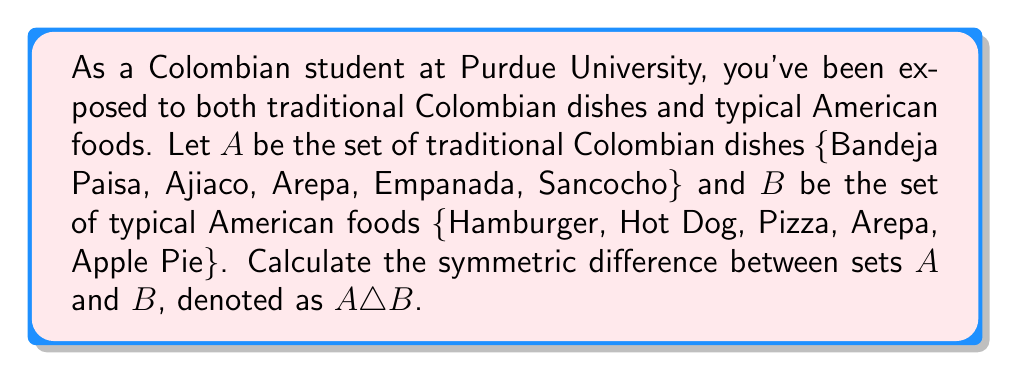What is the answer to this math problem? To solve this problem, we need to follow these steps:

1. Recall the definition of symmetric difference:
   The symmetric difference of two sets $A$ and $B$, denoted as $A \triangle B$, is the set of elements that are in either $A$ or $B$, but not in both.

2. Mathematically, this can be expressed as:
   $A \triangle B = (A \setminus B) \cup (B \setminus A)$
   where $\setminus$ denotes set difference.

3. Let's identify the elements in each set:
   $A = \{Bandeja Paisa, Ajiaco, Arepa, Empanada, Sancocho\}$
   $B = \{Hamburger, Hot Dog, Pizza, Arepa, Apple Pie\}$

4. Find $A \setminus B$ (elements in $A$ but not in $B$):
   $A \setminus B = \{Bandeja Paisa, Ajiaco, Empanada, Sancocho\}$

5. Find $B \setminus A$ (elements in $B$ but not in $A$):
   $B \setminus A = \{Hamburger, Hot Dog, Pizza, Apple Pie\}$

6. Take the union of these two sets:
   $A \triangle B = (A \setminus B) \cup (B \setminus A)$
                 $= \{Bandeja Paisa, Ajiaco, Empanada, Sancocho, Hamburger, Hot Dog, Pizza, Apple Pie\}$

Note that Arepa is not in the symmetric difference because it appears in both sets.
Answer: $A \triangle B = \{Bandeja Paisa, Ajiaco, Empanada, Sancocho, Hamburger, Hot Dog, Pizza, Apple Pie\}$ 